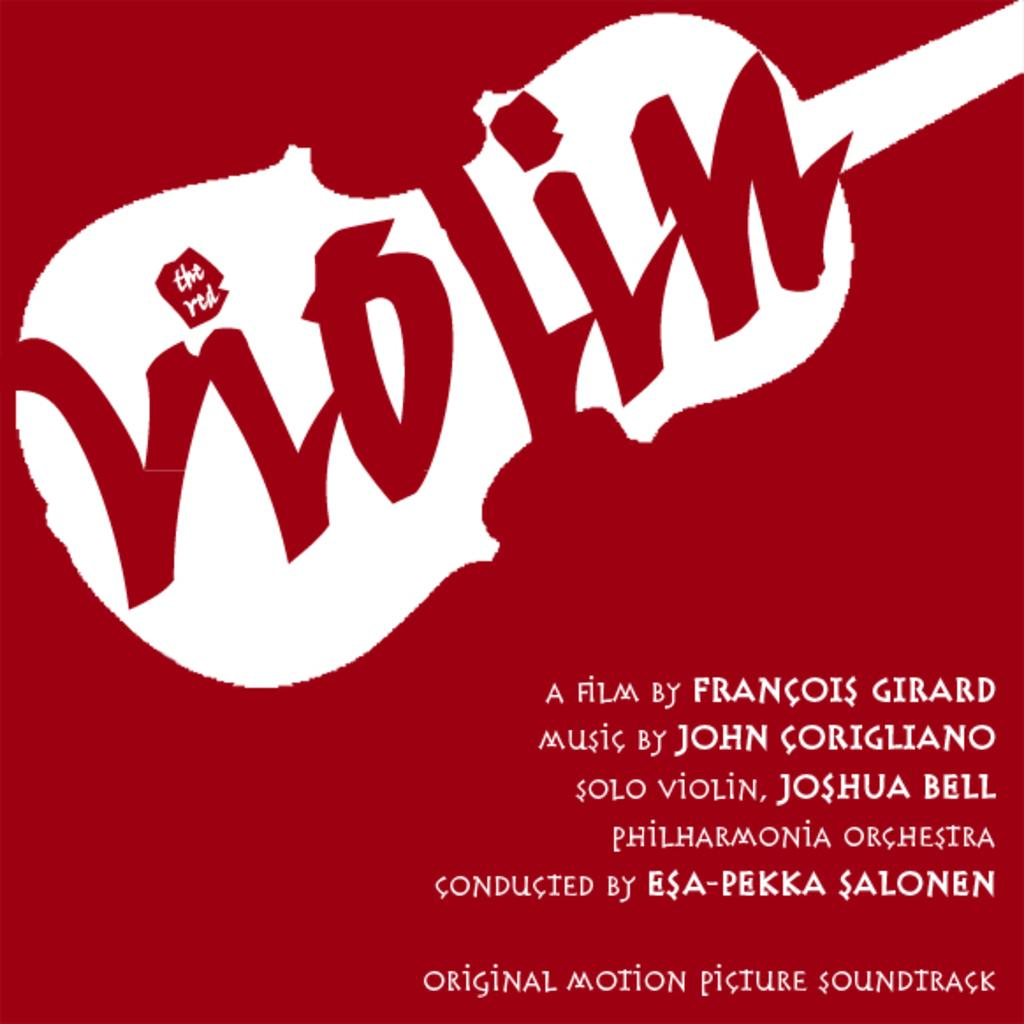<image>
Summarize the visual content of the image. An ad for Violin says that the film is by Francois Girard. 